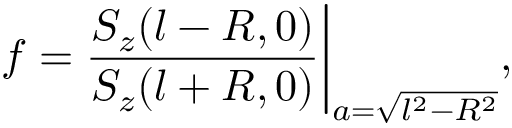Convert formula to latex. <formula><loc_0><loc_0><loc_500><loc_500>f = \frac { S _ { z } ( l - R , 0 ) } { S _ { z } ( l + R , 0 ) } \Big | _ { a = \sqrt { l ^ { 2 } - R ^ { 2 } } } ,</formula> 